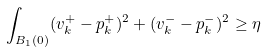<formula> <loc_0><loc_0><loc_500><loc_500>\int _ { B _ { 1 } ( 0 ) } ( v _ { k } ^ { + } - p _ { k } ^ { + } ) ^ { 2 } + ( v _ { k } ^ { - } - p _ { k } ^ { - } ) ^ { 2 } \geq \eta</formula> 